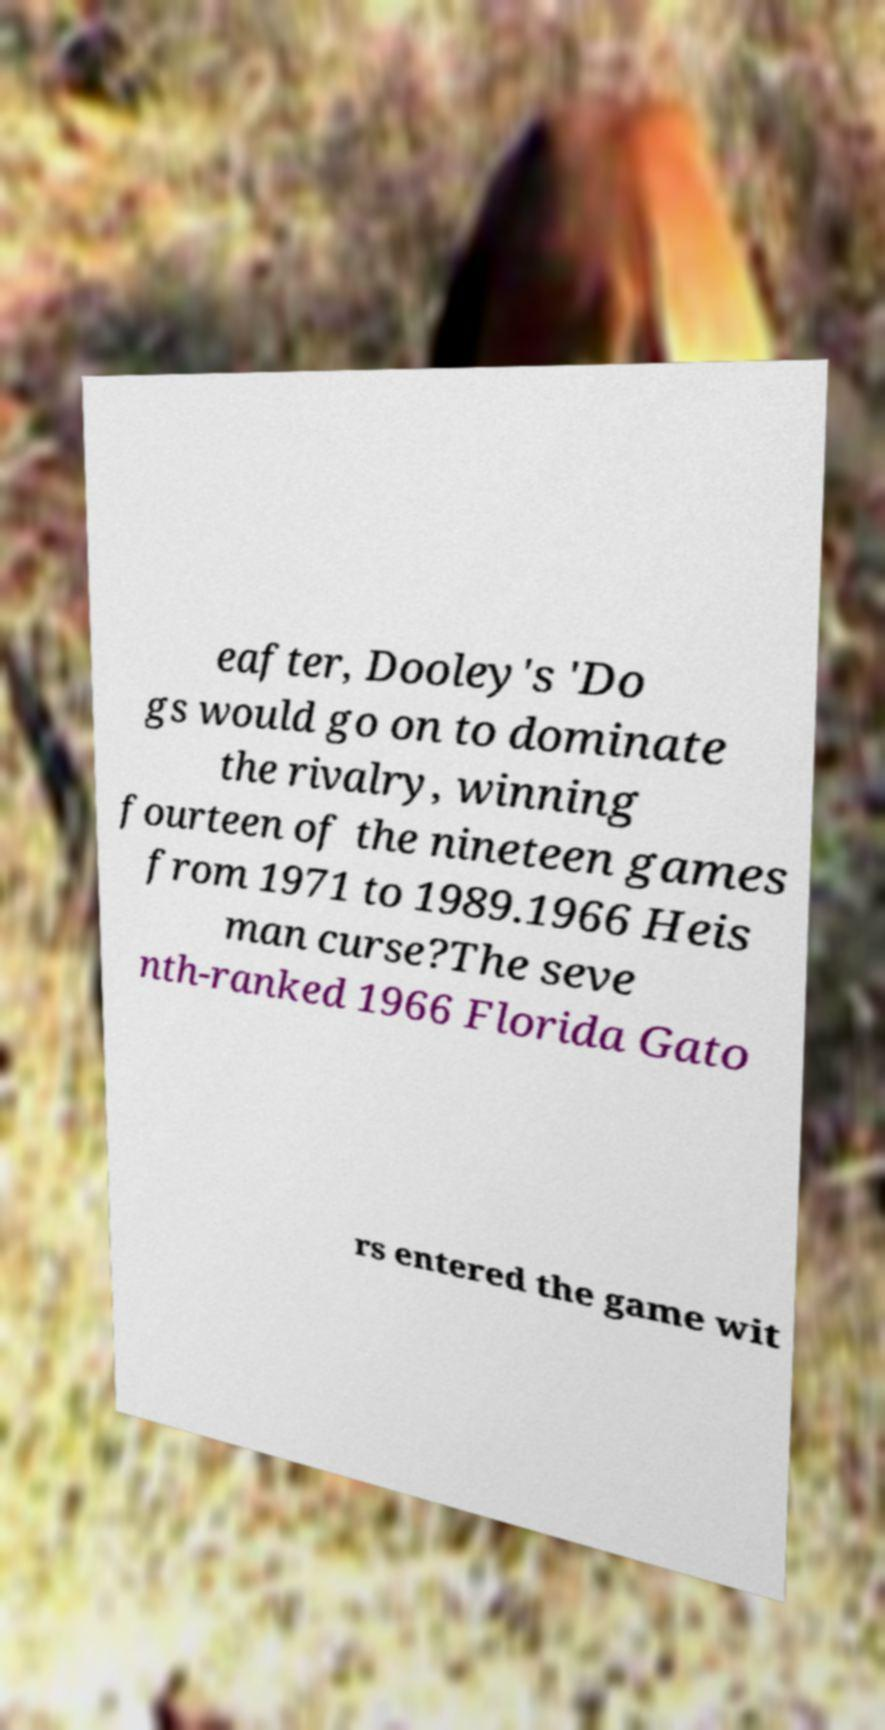What messages or text are displayed in this image? I need them in a readable, typed format. eafter, Dooley's 'Do gs would go on to dominate the rivalry, winning fourteen of the nineteen games from 1971 to 1989.1966 Heis man curse?The seve nth-ranked 1966 Florida Gato rs entered the game wit 